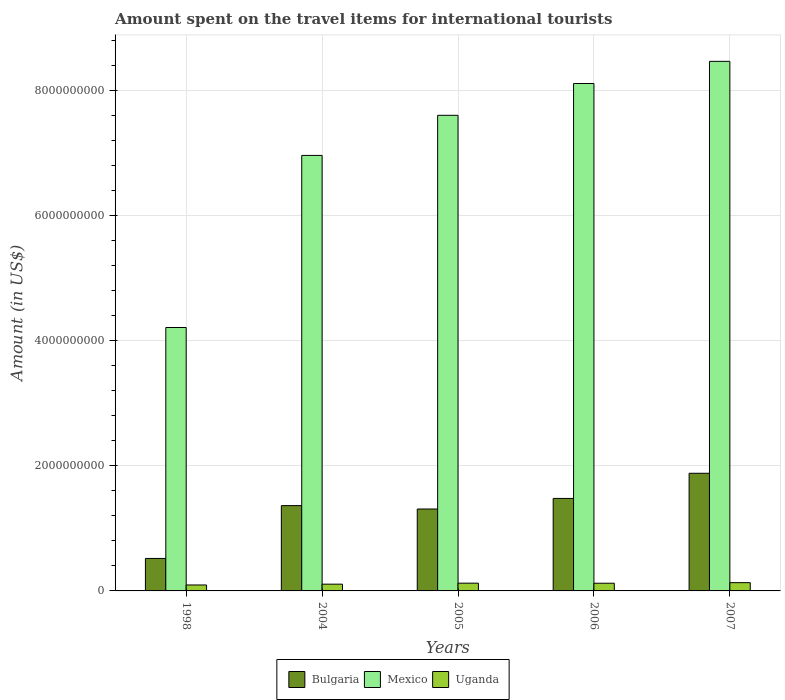How many different coloured bars are there?
Keep it short and to the point. 3. Are the number of bars per tick equal to the number of legend labels?
Ensure brevity in your answer.  Yes. How many bars are there on the 4th tick from the left?
Make the answer very short. 3. What is the amount spent on the travel items for international tourists in Bulgaria in 2005?
Your answer should be very brief. 1.31e+09. Across all years, what is the maximum amount spent on the travel items for international tourists in Uganda?
Offer a terse response. 1.32e+08. Across all years, what is the minimum amount spent on the travel items for international tourists in Uganda?
Offer a terse response. 9.50e+07. In which year was the amount spent on the travel items for international tourists in Uganda minimum?
Your answer should be compact. 1998. What is the total amount spent on the travel items for international tourists in Uganda in the graph?
Keep it short and to the point. 5.82e+08. What is the difference between the amount spent on the travel items for international tourists in Bulgaria in 2005 and that in 2006?
Keep it short and to the point. -1.69e+08. What is the difference between the amount spent on the travel items for international tourists in Bulgaria in 2005 and the amount spent on the travel items for international tourists in Mexico in 2004?
Provide a succinct answer. -5.65e+09. What is the average amount spent on the travel items for international tourists in Mexico per year?
Provide a short and direct response. 7.07e+09. In the year 1998, what is the difference between the amount spent on the travel items for international tourists in Mexico and amount spent on the travel items for international tourists in Uganda?
Your response must be concise. 4.11e+09. What is the ratio of the amount spent on the travel items for international tourists in Bulgaria in 1998 to that in 2006?
Offer a very short reply. 0.35. What is the difference between the highest and the lowest amount spent on the travel items for international tourists in Bulgaria?
Give a very brief answer. 1.36e+09. In how many years, is the amount spent on the travel items for international tourists in Bulgaria greater than the average amount spent on the travel items for international tourists in Bulgaria taken over all years?
Make the answer very short. 3. Is the sum of the amount spent on the travel items for international tourists in Mexico in 1998 and 2006 greater than the maximum amount spent on the travel items for international tourists in Uganda across all years?
Offer a very short reply. Yes. What does the 3rd bar from the left in 2007 represents?
Offer a very short reply. Uganda. What does the 1st bar from the right in 2005 represents?
Ensure brevity in your answer.  Uganda. Is it the case that in every year, the sum of the amount spent on the travel items for international tourists in Uganda and amount spent on the travel items for international tourists in Mexico is greater than the amount spent on the travel items for international tourists in Bulgaria?
Provide a short and direct response. Yes. How many years are there in the graph?
Ensure brevity in your answer.  5. Are the values on the major ticks of Y-axis written in scientific E-notation?
Offer a very short reply. No. Does the graph contain grids?
Provide a short and direct response. Yes. Where does the legend appear in the graph?
Provide a short and direct response. Bottom center. How many legend labels are there?
Offer a terse response. 3. What is the title of the graph?
Your answer should be very brief. Amount spent on the travel items for international tourists. Does "Denmark" appear as one of the legend labels in the graph?
Your answer should be very brief. No. What is the label or title of the X-axis?
Provide a succinct answer. Years. What is the label or title of the Y-axis?
Offer a terse response. Amount (in US$). What is the Amount (in US$) in Bulgaria in 1998?
Provide a succinct answer. 5.19e+08. What is the Amount (in US$) of Mexico in 1998?
Make the answer very short. 4.21e+09. What is the Amount (in US$) of Uganda in 1998?
Your answer should be very brief. 9.50e+07. What is the Amount (in US$) of Bulgaria in 2004?
Your response must be concise. 1.36e+09. What is the Amount (in US$) in Mexico in 2004?
Offer a terse response. 6.96e+09. What is the Amount (in US$) of Uganda in 2004?
Keep it short and to the point. 1.08e+08. What is the Amount (in US$) of Bulgaria in 2005?
Ensure brevity in your answer.  1.31e+09. What is the Amount (in US$) in Mexico in 2005?
Your response must be concise. 7.60e+09. What is the Amount (in US$) of Uganda in 2005?
Your answer should be compact. 1.24e+08. What is the Amount (in US$) in Bulgaria in 2006?
Your answer should be compact. 1.48e+09. What is the Amount (in US$) of Mexico in 2006?
Give a very brief answer. 8.11e+09. What is the Amount (in US$) in Uganda in 2006?
Offer a very short reply. 1.23e+08. What is the Amount (in US$) in Bulgaria in 2007?
Your answer should be compact. 1.88e+09. What is the Amount (in US$) of Mexico in 2007?
Your answer should be compact. 8.46e+09. What is the Amount (in US$) of Uganda in 2007?
Give a very brief answer. 1.32e+08. Across all years, what is the maximum Amount (in US$) in Bulgaria?
Keep it short and to the point. 1.88e+09. Across all years, what is the maximum Amount (in US$) in Mexico?
Your answer should be very brief. 8.46e+09. Across all years, what is the maximum Amount (in US$) of Uganda?
Offer a terse response. 1.32e+08. Across all years, what is the minimum Amount (in US$) in Bulgaria?
Ensure brevity in your answer.  5.19e+08. Across all years, what is the minimum Amount (in US$) of Mexico?
Ensure brevity in your answer.  4.21e+09. Across all years, what is the minimum Amount (in US$) in Uganda?
Ensure brevity in your answer.  9.50e+07. What is the total Amount (in US$) of Bulgaria in the graph?
Provide a succinct answer. 6.55e+09. What is the total Amount (in US$) in Mexico in the graph?
Your answer should be very brief. 3.53e+1. What is the total Amount (in US$) of Uganda in the graph?
Provide a short and direct response. 5.82e+08. What is the difference between the Amount (in US$) of Bulgaria in 1998 and that in 2004?
Offer a terse response. -8.44e+08. What is the difference between the Amount (in US$) of Mexico in 1998 and that in 2004?
Ensure brevity in your answer.  -2.75e+09. What is the difference between the Amount (in US$) of Uganda in 1998 and that in 2004?
Your response must be concise. -1.30e+07. What is the difference between the Amount (in US$) of Bulgaria in 1998 and that in 2005?
Make the answer very short. -7.90e+08. What is the difference between the Amount (in US$) in Mexico in 1998 and that in 2005?
Your answer should be compact. -3.39e+09. What is the difference between the Amount (in US$) of Uganda in 1998 and that in 2005?
Your answer should be very brief. -2.90e+07. What is the difference between the Amount (in US$) in Bulgaria in 1998 and that in 2006?
Your answer should be very brief. -9.59e+08. What is the difference between the Amount (in US$) of Mexico in 1998 and that in 2006?
Make the answer very short. -3.90e+09. What is the difference between the Amount (in US$) of Uganda in 1998 and that in 2006?
Provide a short and direct response. -2.80e+07. What is the difference between the Amount (in US$) in Bulgaria in 1998 and that in 2007?
Keep it short and to the point. -1.36e+09. What is the difference between the Amount (in US$) of Mexico in 1998 and that in 2007?
Make the answer very short. -4.25e+09. What is the difference between the Amount (in US$) of Uganda in 1998 and that in 2007?
Offer a very short reply. -3.70e+07. What is the difference between the Amount (in US$) of Bulgaria in 2004 and that in 2005?
Your answer should be compact. 5.40e+07. What is the difference between the Amount (in US$) of Mexico in 2004 and that in 2005?
Your answer should be compact. -6.41e+08. What is the difference between the Amount (in US$) of Uganda in 2004 and that in 2005?
Give a very brief answer. -1.60e+07. What is the difference between the Amount (in US$) in Bulgaria in 2004 and that in 2006?
Ensure brevity in your answer.  -1.15e+08. What is the difference between the Amount (in US$) in Mexico in 2004 and that in 2006?
Ensure brevity in your answer.  -1.15e+09. What is the difference between the Amount (in US$) of Uganda in 2004 and that in 2006?
Provide a short and direct response. -1.50e+07. What is the difference between the Amount (in US$) in Bulgaria in 2004 and that in 2007?
Your answer should be compact. -5.17e+08. What is the difference between the Amount (in US$) of Mexico in 2004 and that in 2007?
Your response must be concise. -1.50e+09. What is the difference between the Amount (in US$) in Uganda in 2004 and that in 2007?
Provide a succinct answer. -2.40e+07. What is the difference between the Amount (in US$) of Bulgaria in 2005 and that in 2006?
Provide a succinct answer. -1.69e+08. What is the difference between the Amount (in US$) of Mexico in 2005 and that in 2006?
Offer a terse response. -5.08e+08. What is the difference between the Amount (in US$) of Uganda in 2005 and that in 2006?
Offer a terse response. 1.00e+06. What is the difference between the Amount (in US$) in Bulgaria in 2005 and that in 2007?
Ensure brevity in your answer.  -5.71e+08. What is the difference between the Amount (in US$) in Mexico in 2005 and that in 2007?
Your answer should be compact. -8.62e+08. What is the difference between the Amount (in US$) in Uganda in 2005 and that in 2007?
Give a very brief answer. -8.00e+06. What is the difference between the Amount (in US$) of Bulgaria in 2006 and that in 2007?
Offer a very short reply. -4.02e+08. What is the difference between the Amount (in US$) in Mexico in 2006 and that in 2007?
Keep it short and to the point. -3.54e+08. What is the difference between the Amount (in US$) in Uganda in 2006 and that in 2007?
Offer a terse response. -9.00e+06. What is the difference between the Amount (in US$) in Bulgaria in 1998 and the Amount (in US$) in Mexico in 2004?
Your response must be concise. -6.44e+09. What is the difference between the Amount (in US$) in Bulgaria in 1998 and the Amount (in US$) in Uganda in 2004?
Ensure brevity in your answer.  4.11e+08. What is the difference between the Amount (in US$) in Mexico in 1998 and the Amount (in US$) in Uganda in 2004?
Keep it short and to the point. 4.10e+09. What is the difference between the Amount (in US$) of Bulgaria in 1998 and the Amount (in US$) of Mexico in 2005?
Your response must be concise. -7.08e+09. What is the difference between the Amount (in US$) in Bulgaria in 1998 and the Amount (in US$) in Uganda in 2005?
Your response must be concise. 3.95e+08. What is the difference between the Amount (in US$) in Mexico in 1998 and the Amount (in US$) in Uganda in 2005?
Your answer should be very brief. 4.08e+09. What is the difference between the Amount (in US$) in Bulgaria in 1998 and the Amount (in US$) in Mexico in 2006?
Your answer should be compact. -7.59e+09. What is the difference between the Amount (in US$) of Bulgaria in 1998 and the Amount (in US$) of Uganda in 2006?
Your response must be concise. 3.96e+08. What is the difference between the Amount (in US$) in Mexico in 1998 and the Amount (in US$) in Uganda in 2006?
Ensure brevity in your answer.  4.09e+09. What is the difference between the Amount (in US$) in Bulgaria in 1998 and the Amount (in US$) in Mexico in 2007?
Give a very brief answer. -7.94e+09. What is the difference between the Amount (in US$) in Bulgaria in 1998 and the Amount (in US$) in Uganda in 2007?
Offer a terse response. 3.87e+08. What is the difference between the Amount (in US$) of Mexico in 1998 and the Amount (in US$) of Uganda in 2007?
Give a very brief answer. 4.08e+09. What is the difference between the Amount (in US$) in Bulgaria in 2004 and the Amount (in US$) in Mexico in 2005?
Offer a very short reply. -6.24e+09. What is the difference between the Amount (in US$) in Bulgaria in 2004 and the Amount (in US$) in Uganda in 2005?
Your response must be concise. 1.24e+09. What is the difference between the Amount (in US$) of Mexico in 2004 and the Amount (in US$) of Uganda in 2005?
Your answer should be compact. 6.84e+09. What is the difference between the Amount (in US$) in Bulgaria in 2004 and the Amount (in US$) in Mexico in 2006?
Your answer should be compact. -6.74e+09. What is the difference between the Amount (in US$) of Bulgaria in 2004 and the Amount (in US$) of Uganda in 2006?
Offer a very short reply. 1.24e+09. What is the difference between the Amount (in US$) of Mexico in 2004 and the Amount (in US$) of Uganda in 2006?
Your response must be concise. 6.84e+09. What is the difference between the Amount (in US$) of Bulgaria in 2004 and the Amount (in US$) of Mexico in 2007?
Your answer should be very brief. -7.10e+09. What is the difference between the Amount (in US$) of Bulgaria in 2004 and the Amount (in US$) of Uganda in 2007?
Provide a short and direct response. 1.23e+09. What is the difference between the Amount (in US$) in Mexico in 2004 and the Amount (in US$) in Uganda in 2007?
Offer a terse response. 6.83e+09. What is the difference between the Amount (in US$) in Bulgaria in 2005 and the Amount (in US$) in Mexico in 2006?
Keep it short and to the point. -6.80e+09. What is the difference between the Amount (in US$) of Bulgaria in 2005 and the Amount (in US$) of Uganda in 2006?
Your answer should be very brief. 1.19e+09. What is the difference between the Amount (in US$) in Mexico in 2005 and the Amount (in US$) in Uganda in 2006?
Ensure brevity in your answer.  7.48e+09. What is the difference between the Amount (in US$) of Bulgaria in 2005 and the Amount (in US$) of Mexico in 2007?
Offer a very short reply. -7.15e+09. What is the difference between the Amount (in US$) in Bulgaria in 2005 and the Amount (in US$) in Uganda in 2007?
Your answer should be very brief. 1.18e+09. What is the difference between the Amount (in US$) in Mexico in 2005 and the Amount (in US$) in Uganda in 2007?
Provide a succinct answer. 7.47e+09. What is the difference between the Amount (in US$) in Bulgaria in 2006 and the Amount (in US$) in Mexico in 2007?
Offer a terse response. -6.98e+09. What is the difference between the Amount (in US$) in Bulgaria in 2006 and the Amount (in US$) in Uganda in 2007?
Keep it short and to the point. 1.35e+09. What is the difference between the Amount (in US$) in Mexico in 2006 and the Amount (in US$) in Uganda in 2007?
Your answer should be compact. 7.98e+09. What is the average Amount (in US$) in Bulgaria per year?
Make the answer very short. 1.31e+09. What is the average Amount (in US$) in Mexico per year?
Your answer should be very brief. 7.07e+09. What is the average Amount (in US$) of Uganda per year?
Keep it short and to the point. 1.16e+08. In the year 1998, what is the difference between the Amount (in US$) in Bulgaria and Amount (in US$) in Mexico?
Your response must be concise. -3.69e+09. In the year 1998, what is the difference between the Amount (in US$) in Bulgaria and Amount (in US$) in Uganda?
Offer a terse response. 4.24e+08. In the year 1998, what is the difference between the Amount (in US$) of Mexico and Amount (in US$) of Uganda?
Give a very brief answer. 4.11e+09. In the year 2004, what is the difference between the Amount (in US$) in Bulgaria and Amount (in US$) in Mexico?
Keep it short and to the point. -5.60e+09. In the year 2004, what is the difference between the Amount (in US$) in Bulgaria and Amount (in US$) in Uganda?
Ensure brevity in your answer.  1.26e+09. In the year 2004, what is the difference between the Amount (in US$) in Mexico and Amount (in US$) in Uganda?
Provide a short and direct response. 6.85e+09. In the year 2005, what is the difference between the Amount (in US$) in Bulgaria and Amount (in US$) in Mexico?
Make the answer very short. -6.29e+09. In the year 2005, what is the difference between the Amount (in US$) in Bulgaria and Amount (in US$) in Uganda?
Provide a succinct answer. 1.18e+09. In the year 2005, what is the difference between the Amount (in US$) in Mexico and Amount (in US$) in Uganda?
Offer a very short reply. 7.48e+09. In the year 2006, what is the difference between the Amount (in US$) of Bulgaria and Amount (in US$) of Mexico?
Provide a succinct answer. -6.63e+09. In the year 2006, what is the difference between the Amount (in US$) in Bulgaria and Amount (in US$) in Uganda?
Offer a very short reply. 1.36e+09. In the year 2006, what is the difference between the Amount (in US$) in Mexico and Amount (in US$) in Uganda?
Your response must be concise. 7.98e+09. In the year 2007, what is the difference between the Amount (in US$) of Bulgaria and Amount (in US$) of Mexico?
Provide a short and direct response. -6.58e+09. In the year 2007, what is the difference between the Amount (in US$) in Bulgaria and Amount (in US$) in Uganda?
Keep it short and to the point. 1.75e+09. In the year 2007, what is the difference between the Amount (in US$) of Mexico and Amount (in US$) of Uganda?
Provide a short and direct response. 8.33e+09. What is the ratio of the Amount (in US$) in Bulgaria in 1998 to that in 2004?
Your answer should be compact. 0.38. What is the ratio of the Amount (in US$) in Mexico in 1998 to that in 2004?
Give a very brief answer. 0.6. What is the ratio of the Amount (in US$) in Uganda in 1998 to that in 2004?
Make the answer very short. 0.88. What is the ratio of the Amount (in US$) in Bulgaria in 1998 to that in 2005?
Make the answer very short. 0.4. What is the ratio of the Amount (in US$) of Mexico in 1998 to that in 2005?
Provide a succinct answer. 0.55. What is the ratio of the Amount (in US$) in Uganda in 1998 to that in 2005?
Ensure brevity in your answer.  0.77. What is the ratio of the Amount (in US$) in Bulgaria in 1998 to that in 2006?
Your answer should be compact. 0.35. What is the ratio of the Amount (in US$) of Mexico in 1998 to that in 2006?
Provide a succinct answer. 0.52. What is the ratio of the Amount (in US$) in Uganda in 1998 to that in 2006?
Offer a terse response. 0.77. What is the ratio of the Amount (in US$) in Bulgaria in 1998 to that in 2007?
Your response must be concise. 0.28. What is the ratio of the Amount (in US$) in Mexico in 1998 to that in 2007?
Your response must be concise. 0.5. What is the ratio of the Amount (in US$) of Uganda in 1998 to that in 2007?
Your answer should be very brief. 0.72. What is the ratio of the Amount (in US$) in Bulgaria in 2004 to that in 2005?
Keep it short and to the point. 1.04. What is the ratio of the Amount (in US$) of Mexico in 2004 to that in 2005?
Your response must be concise. 0.92. What is the ratio of the Amount (in US$) of Uganda in 2004 to that in 2005?
Your answer should be compact. 0.87. What is the ratio of the Amount (in US$) of Bulgaria in 2004 to that in 2006?
Offer a very short reply. 0.92. What is the ratio of the Amount (in US$) of Mexico in 2004 to that in 2006?
Your response must be concise. 0.86. What is the ratio of the Amount (in US$) in Uganda in 2004 to that in 2006?
Keep it short and to the point. 0.88. What is the ratio of the Amount (in US$) of Bulgaria in 2004 to that in 2007?
Your answer should be compact. 0.72. What is the ratio of the Amount (in US$) of Mexico in 2004 to that in 2007?
Your answer should be very brief. 0.82. What is the ratio of the Amount (in US$) in Uganda in 2004 to that in 2007?
Provide a succinct answer. 0.82. What is the ratio of the Amount (in US$) of Bulgaria in 2005 to that in 2006?
Offer a very short reply. 0.89. What is the ratio of the Amount (in US$) of Mexico in 2005 to that in 2006?
Make the answer very short. 0.94. What is the ratio of the Amount (in US$) of Uganda in 2005 to that in 2006?
Ensure brevity in your answer.  1.01. What is the ratio of the Amount (in US$) in Bulgaria in 2005 to that in 2007?
Make the answer very short. 0.7. What is the ratio of the Amount (in US$) of Mexico in 2005 to that in 2007?
Your response must be concise. 0.9. What is the ratio of the Amount (in US$) in Uganda in 2005 to that in 2007?
Your answer should be very brief. 0.94. What is the ratio of the Amount (in US$) in Bulgaria in 2006 to that in 2007?
Make the answer very short. 0.79. What is the ratio of the Amount (in US$) in Mexico in 2006 to that in 2007?
Ensure brevity in your answer.  0.96. What is the ratio of the Amount (in US$) of Uganda in 2006 to that in 2007?
Ensure brevity in your answer.  0.93. What is the difference between the highest and the second highest Amount (in US$) in Bulgaria?
Keep it short and to the point. 4.02e+08. What is the difference between the highest and the second highest Amount (in US$) of Mexico?
Keep it short and to the point. 3.54e+08. What is the difference between the highest and the second highest Amount (in US$) of Uganda?
Provide a short and direct response. 8.00e+06. What is the difference between the highest and the lowest Amount (in US$) of Bulgaria?
Offer a terse response. 1.36e+09. What is the difference between the highest and the lowest Amount (in US$) in Mexico?
Make the answer very short. 4.25e+09. What is the difference between the highest and the lowest Amount (in US$) of Uganda?
Your answer should be compact. 3.70e+07. 